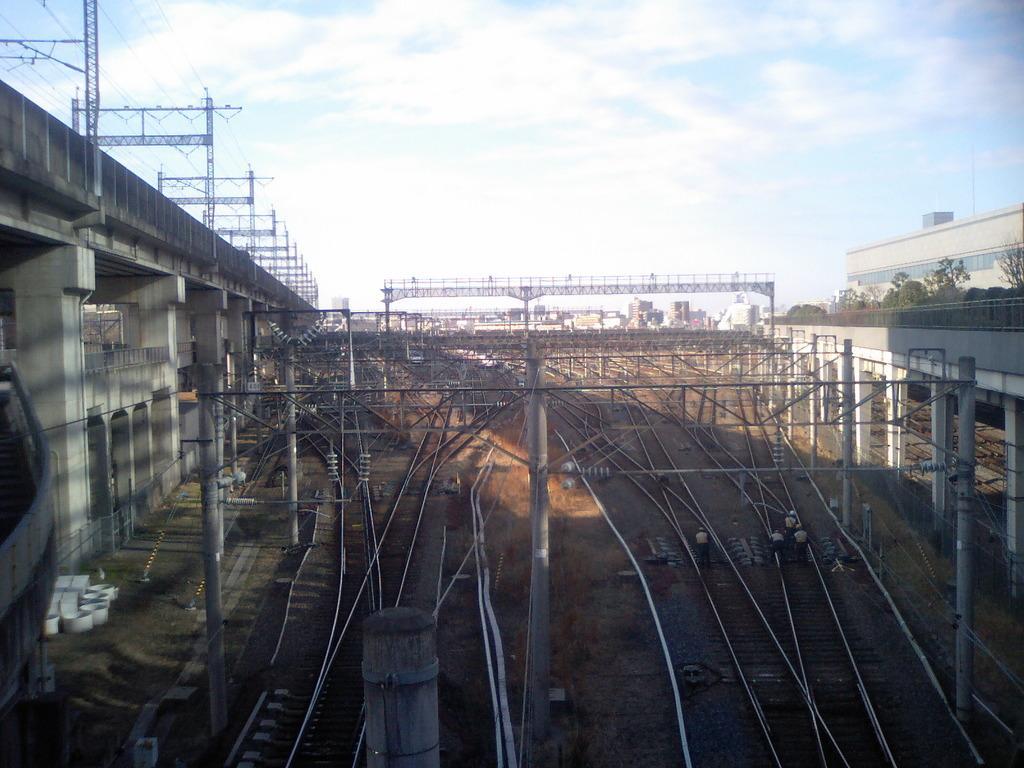Please provide a concise description of this image. In this image at the bottom there is one railway track and some poles and wires, and some towers in the background there are some buildings. On the right side and left side there is a bridge pillars and some towers, on the top of the image there is sky. 